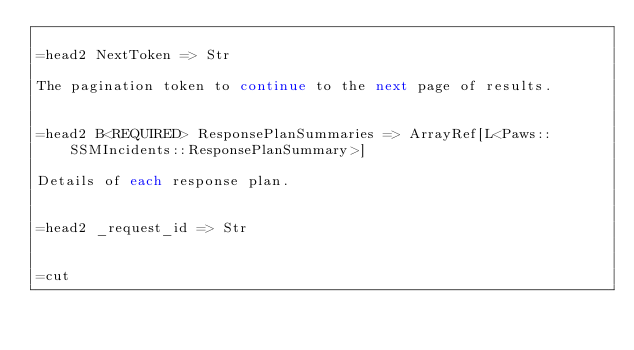<code> <loc_0><loc_0><loc_500><loc_500><_Perl_>
=head2 NextToken => Str

The pagination token to continue to the next page of results.


=head2 B<REQUIRED> ResponsePlanSummaries => ArrayRef[L<Paws::SSMIncidents::ResponsePlanSummary>]

Details of each response plan.


=head2 _request_id => Str


=cut

</code> 